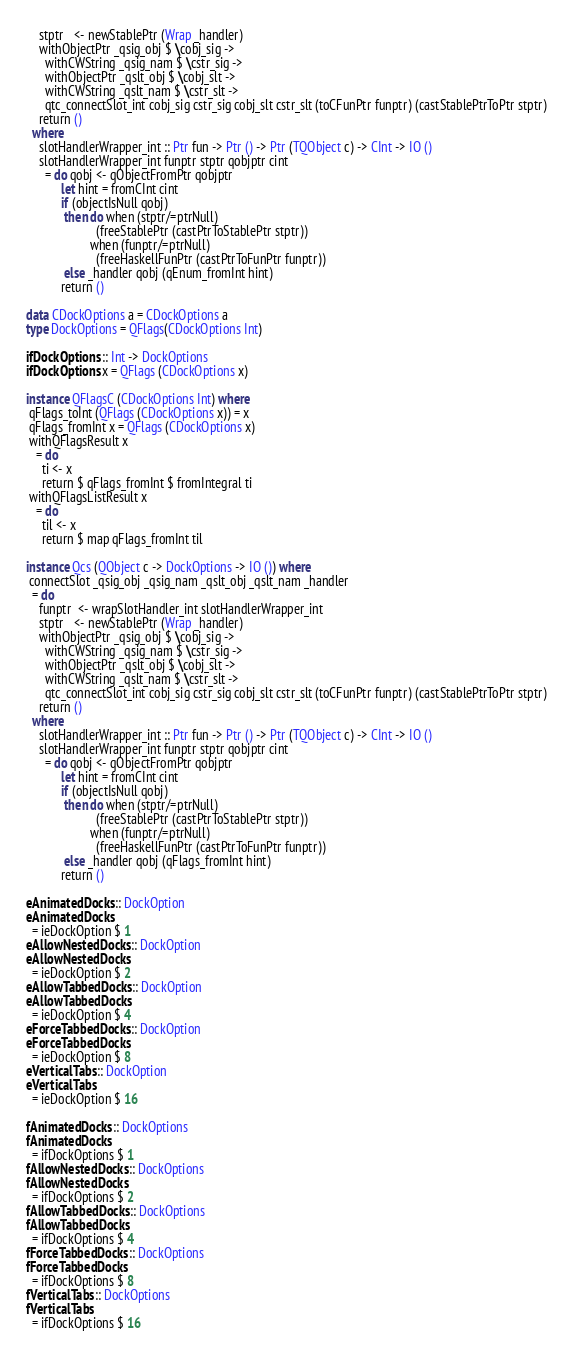Convert code to text. <code><loc_0><loc_0><loc_500><loc_500><_Haskell_>    stptr   <- newStablePtr (Wrap _handler)
    withObjectPtr _qsig_obj $ \cobj_sig ->
      withCWString _qsig_nam $ \cstr_sig ->
      withObjectPtr _qslt_obj $ \cobj_slt ->
      withCWString _qslt_nam $ \cstr_slt ->
      qtc_connectSlot_int cobj_sig cstr_sig cobj_slt cstr_slt (toCFunPtr funptr) (castStablePtrToPtr stptr)
    return ()
  where
    slotHandlerWrapper_int :: Ptr fun -> Ptr () -> Ptr (TQObject c) -> CInt -> IO ()
    slotHandlerWrapper_int funptr stptr qobjptr cint
      = do qobj <- qObjectFromPtr qobjptr
           let hint = fromCInt cint
           if (objectIsNull qobj)
            then do when (stptr/=ptrNull)
                      (freeStablePtr (castPtrToStablePtr stptr))
                    when (funptr/=ptrNull)
                      (freeHaskellFunPtr (castPtrToFunPtr funptr))
            else _handler qobj (qEnum_fromInt hint)
           return ()

data CDockOptions a = CDockOptions a
type DockOptions = QFlags(CDockOptions Int)

ifDockOptions :: Int -> DockOptions
ifDockOptions x = QFlags (CDockOptions x)

instance QFlagsC (CDockOptions Int) where
 qFlags_toInt (QFlags (CDockOptions x)) = x
 qFlags_fromInt x = QFlags (CDockOptions x)
 withQFlagsResult x
   = do
     ti <- x
     return $ qFlags_fromInt $ fromIntegral ti
 withQFlagsListResult x
   = do
     til <- x
     return $ map qFlags_fromInt til

instance Qcs (QObject c -> DockOptions -> IO ()) where
 connectSlot _qsig_obj _qsig_nam _qslt_obj _qslt_nam _handler
  = do
    funptr  <- wrapSlotHandler_int slotHandlerWrapper_int
    stptr   <- newStablePtr (Wrap _handler)
    withObjectPtr _qsig_obj $ \cobj_sig ->
      withCWString _qsig_nam $ \cstr_sig ->
      withObjectPtr _qslt_obj $ \cobj_slt ->
      withCWString _qslt_nam $ \cstr_slt ->
      qtc_connectSlot_int cobj_sig cstr_sig cobj_slt cstr_slt (toCFunPtr funptr) (castStablePtrToPtr stptr)
    return ()
  where
    slotHandlerWrapper_int :: Ptr fun -> Ptr () -> Ptr (TQObject c) -> CInt -> IO ()
    slotHandlerWrapper_int funptr stptr qobjptr cint
      = do qobj <- qObjectFromPtr qobjptr
           let hint = fromCInt cint
           if (objectIsNull qobj)
            then do when (stptr/=ptrNull)
                      (freeStablePtr (castPtrToStablePtr stptr))
                    when (funptr/=ptrNull)
                      (freeHaskellFunPtr (castPtrToFunPtr funptr))
            else _handler qobj (qFlags_fromInt hint)
           return ()

eAnimatedDocks :: DockOption
eAnimatedDocks
  = ieDockOption $ 1
eAllowNestedDocks :: DockOption
eAllowNestedDocks
  = ieDockOption $ 2
eAllowTabbedDocks :: DockOption
eAllowTabbedDocks
  = ieDockOption $ 4
eForceTabbedDocks :: DockOption
eForceTabbedDocks
  = ieDockOption $ 8
eVerticalTabs :: DockOption
eVerticalTabs
  = ieDockOption $ 16

fAnimatedDocks :: DockOptions
fAnimatedDocks
  = ifDockOptions $ 1
fAllowNestedDocks :: DockOptions
fAllowNestedDocks
  = ifDockOptions $ 2
fAllowTabbedDocks :: DockOptions
fAllowTabbedDocks
  = ifDockOptions $ 4
fForceTabbedDocks :: DockOptions
fForceTabbedDocks
  = ifDockOptions $ 8
fVerticalTabs :: DockOptions
fVerticalTabs
  = ifDockOptions $ 16

</code> 